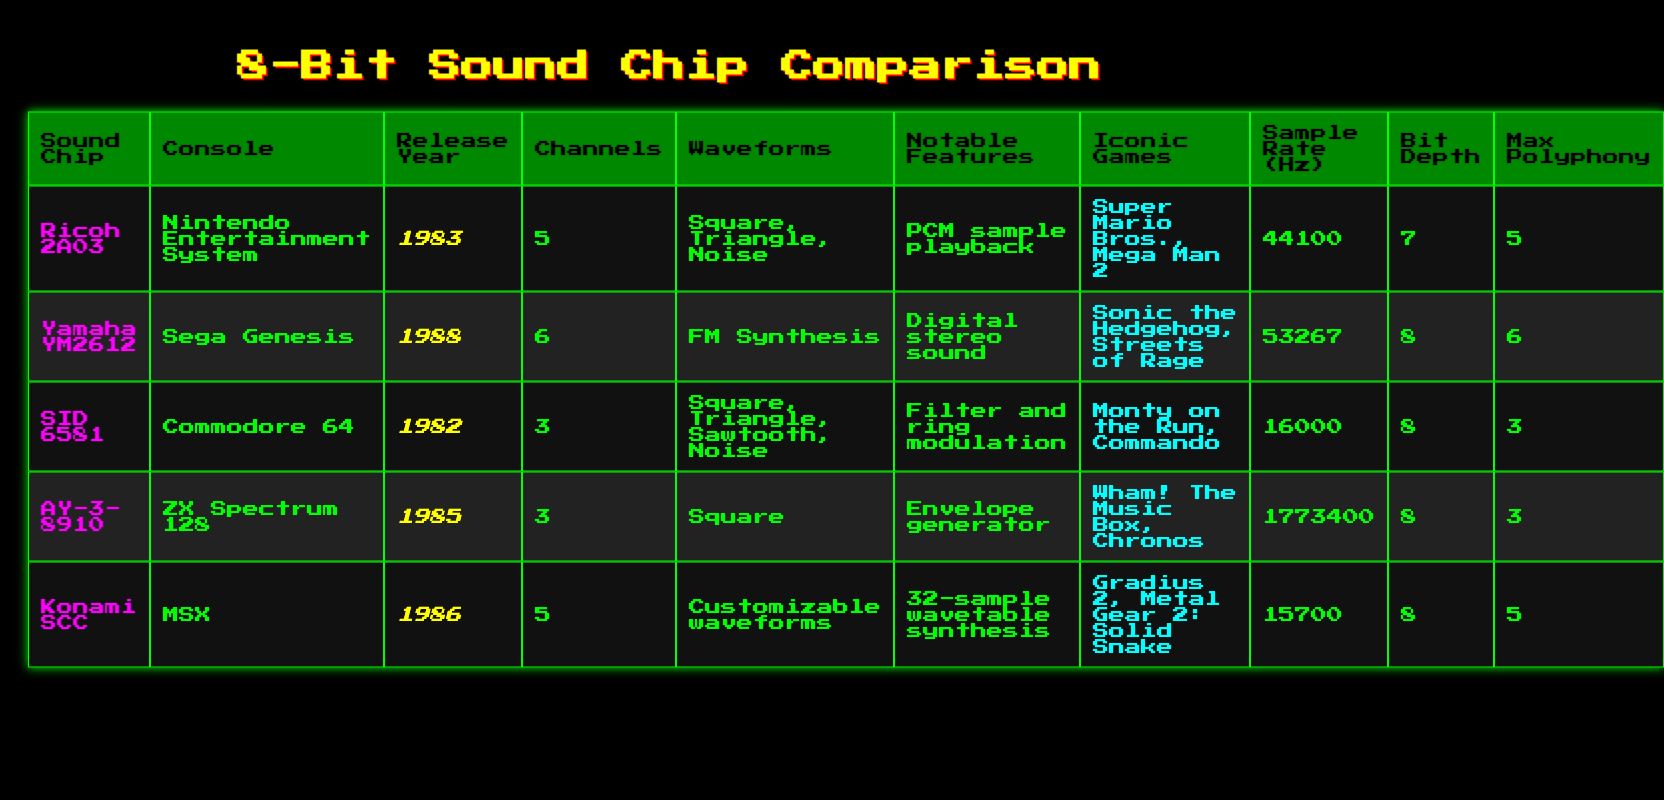What is the release year of the Yamaha YM2612? The table states that the Yamaha YM2612 was released in 1988.
Answer: 1988 Which sound chip has the highest sample rate? By examining the sample rate values, the AY-3-8910 has a sample rate of 1773400 Hz, which is the highest among all listed sound chips.
Answer: AY-3-8910 How many channels does the SID 6581 have? The table indicates that the SID 6581 has 3 channels.
Answer: 3 Is it true that the Ricoh 2A03 is compatible with the Sega Genesis? According to the table, the Ricoh 2A03 is used in the Nintendo Entertainment System, not the Sega Genesis, so this statement is false.
Answer: False What is the sum of the max polyphony of all sound chips listed? The max polyphony values are 5, 6, 3, 3, and 5. Adding these together (5 + 6 + 3 + 3 + 5) gives a sum of 22.
Answer: 22 Which console is associated with the sound chip that features FM synthesis? The Yamaha YM2612 is the sound chip with FM synthesis, and it is associated with the Sega Genesis.
Answer: Sega Genesis Find the average bit depth of the sound chips presented. The bit depths are 7, 8, 8, 8, and 8. Adding them gives 39. Dividing by the number of chips (5) yields an average of 39/5 = 7.8.
Answer: 7.8 What notable features are present in the AY-3-8910 sound chip? The AY-3-8910 features an envelope generator, as stated in the table.
Answer: Envelope generator Which iconic game is associated with the SID 6581? The table lists "Monty on the Run" and "Commando" as iconic games associated with the SID 6581.
Answer: Monty on the Run, Commando 